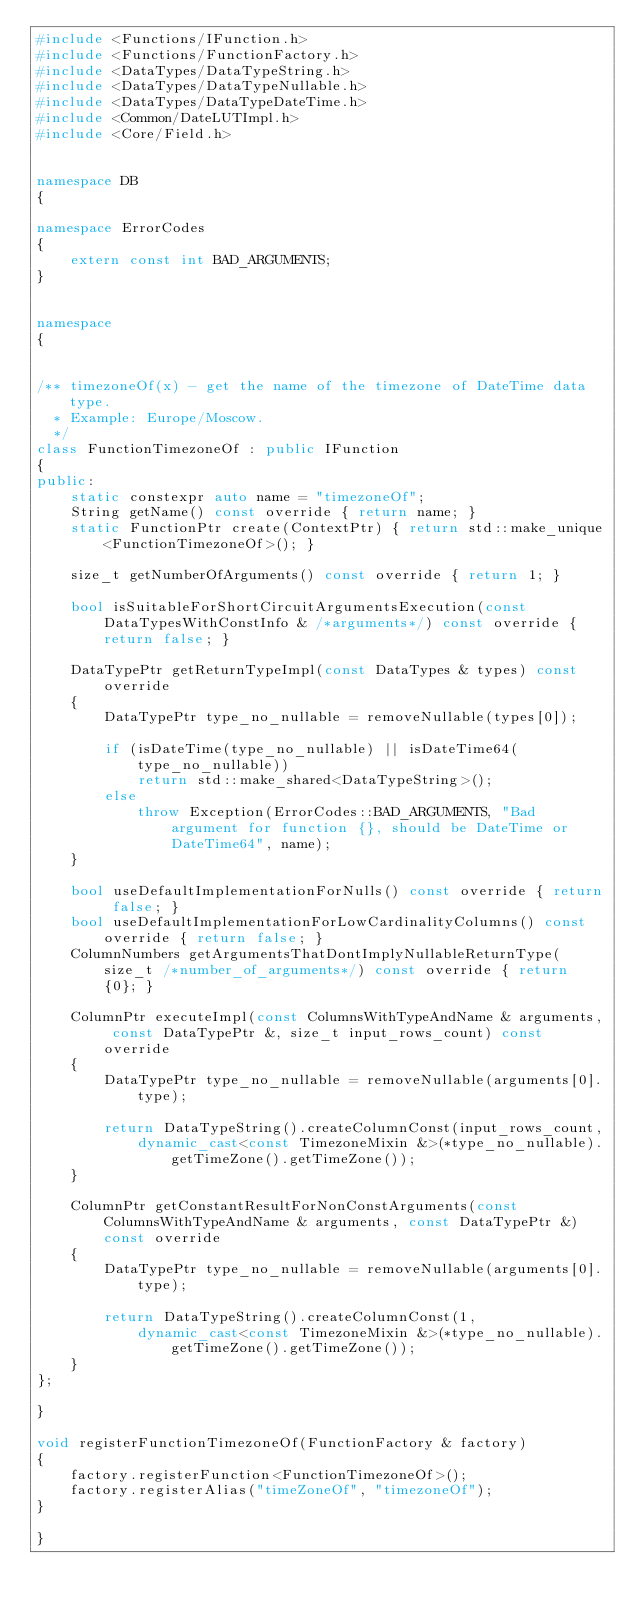Convert code to text. <code><loc_0><loc_0><loc_500><loc_500><_C++_>#include <Functions/IFunction.h>
#include <Functions/FunctionFactory.h>
#include <DataTypes/DataTypeString.h>
#include <DataTypes/DataTypeNullable.h>
#include <DataTypes/DataTypeDateTime.h>
#include <Common/DateLUTImpl.h>
#include <Core/Field.h>


namespace DB
{

namespace ErrorCodes
{
    extern const int BAD_ARGUMENTS;
}


namespace
{


/** timezoneOf(x) - get the name of the timezone of DateTime data type.
  * Example: Europe/Moscow.
  */
class FunctionTimezoneOf : public IFunction
{
public:
    static constexpr auto name = "timezoneOf";
    String getName() const override { return name; }
    static FunctionPtr create(ContextPtr) { return std::make_unique<FunctionTimezoneOf>(); }

    size_t getNumberOfArguments() const override { return 1; }

    bool isSuitableForShortCircuitArgumentsExecution(const DataTypesWithConstInfo & /*arguments*/) const override { return false; }

    DataTypePtr getReturnTypeImpl(const DataTypes & types) const override
    {
        DataTypePtr type_no_nullable = removeNullable(types[0]);

        if (isDateTime(type_no_nullable) || isDateTime64(type_no_nullable))
            return std::make_shared<DataTypeString>();
        else
            throw Exception(ErrorCodes::BAD_ARGUMENTS, "Bad argument for function {}, should be DateTime or DateTime64", name);
    }

    bool useDefaultImplementationForNulls() const override { return false; }
    bool useDefaultImplementationForLowCardinalityColumns() const override { return false; }
    ColumnNumbers getArgumentsThatDontImplyNullableReturnType(size_t /*number_of_arguments*/) const override { return {0}; }

    ColumnPtr executeImpl(const ColumnsWithTypeAndName & arguments, const DataTypePtr &, size_t input_rows_count) const override
    {
        DataTypePtr type_no_nullable = removeNullable(arguments[0].type);

        return DataTypeString().createColumnConst(input_rows_count,
            dynamic_cast<const TimezoneMixin &>(*type_no_nullable).getTimeZone().getTimeZone());
    }

    ColumnPtr getConstantResultForNonConstArguments(const ColumnsWithTypeAndName & arguments, const DataTypePtr &) const override
    {
        DataTypePtr type_no_nullable = removeNullable(arguments[0].type);

        return DataTypeString().createColumnConst(1,
            dynamic_cast<const TimezoneMixin &>(*type_no_nullable).getTimeZone().getTimeZone());
    }
};

}

void registerFunctionTimezoneOf(FunctionFactory & factory)
{
    factory.registerFunction<FunctionTimezoneOf>();
    factory.registerAlias("timeZoneOf", "timezoneOf");
}

}

</code> 